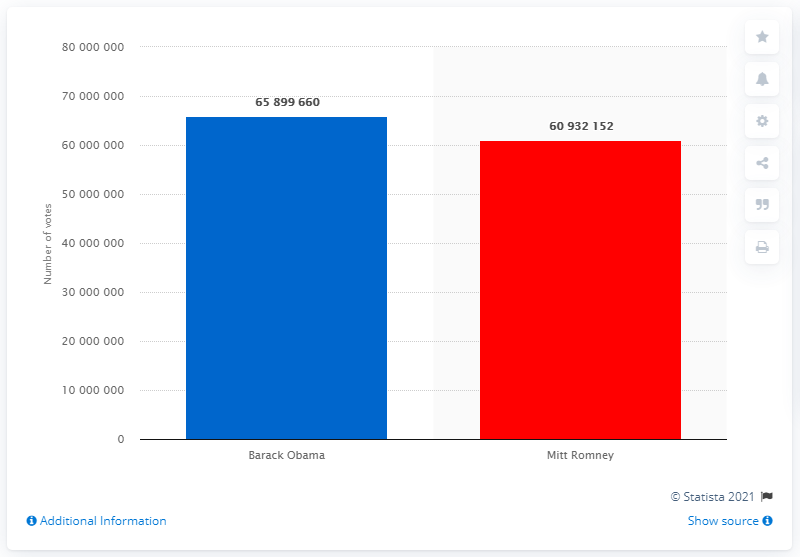Point out several critical features in this image. Mitt Romney received 609,321,527 votes in the election. President Barack Obama received 65,899,660 votes during his tenure in office. 